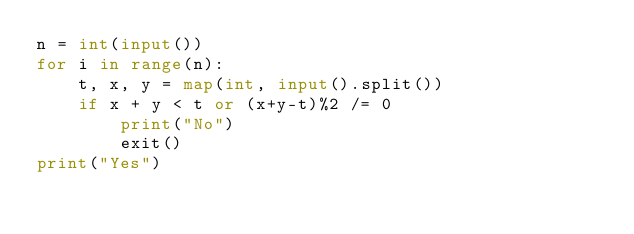<code> <loc_0><loc_0><loc_500><loc_500><_Python_>n = int(input())
for i in range(n):
    t, x, y = map(int, input().split())
    if x + y < t or (x+y-t)%2 /= 0
        print("No")
        exit()
print("Yes")</code> 